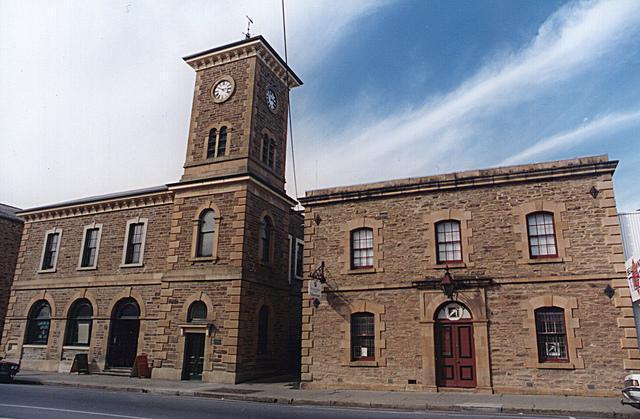How many sides can you see a clock on?
Give a very brief answer. 2. How many buildings do you see?
Give a very brief answer. 2. 